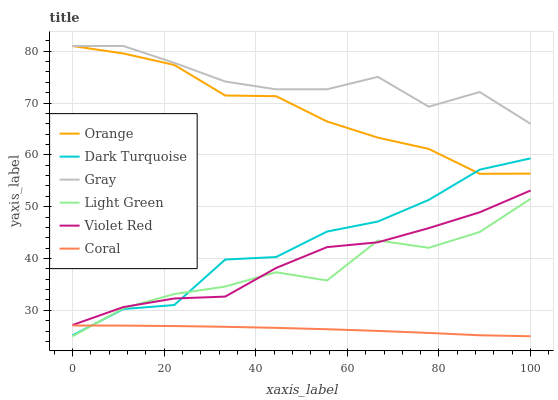Does Coral have the minimum area under the curve?
Answer yes or no. Yes. Does Gray have the maximum area under the curve?
Answer yes or no. Yes. Does Violet Red have the minimum area under the curve?
Answer yes or no. No. Does Violet Red have the maximum area under the curve?
Answer yes or no. No. Is Coral the smoothest?
Answer yes or no. Yes. Is Light Green the roughest?
Answer yes or no. Yes. Is Violet Red the smoothest?
Answer yes or no. No. Is Violet Red the roughest?
Answer yes or no. No. Does Coral have the lowest value?
Answer yes or no. Yes. Does Violet Red have the lowest value?
Answer yes or no. No. Does Orange have the highest value?
Answer yes or no. Yes. Does Violet Red have the highest value?
Answer yes or no. No. Is Violet Red less than Gray?
Answer yes or no. Yes. Is Orange greater than Light Green?
Answer yes or no. Yes. Does Light Green intersect Dark Turquoise?
Answer yes or no. Yes. Is Light Green less than Dark Turquoise?
Answer yes or no. No. Is Light Green greater than Dark Turquoise?
Answer yes or no. No. Does Violet Red intersect Gray?
Answer yes or no. No. 